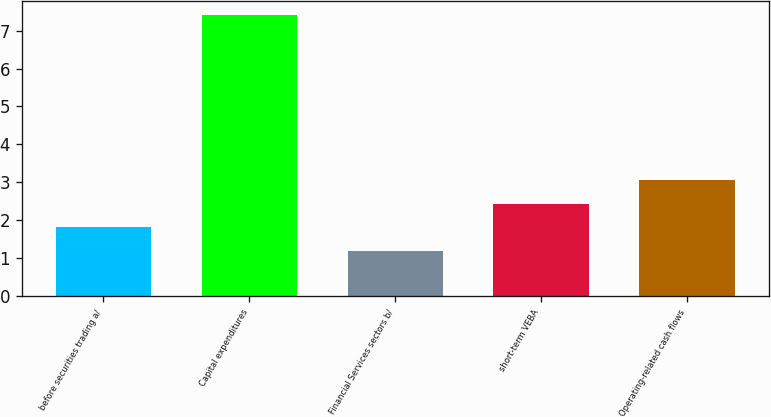Convert chart to OTSL. <chart><loc_0><loc_0><loc_500><loc_500><bar_chart><fcel>before securities trading a/<fcel>Capital expenditures<fcel>Financial Services sectors b/<fcel>short-term VEBA<fcel>Operating-related cash flows<nl><fcel>1.82<fcel>7.4<fcel>1.2<fcel>2.44<fcel>3.06<nl></chart> 